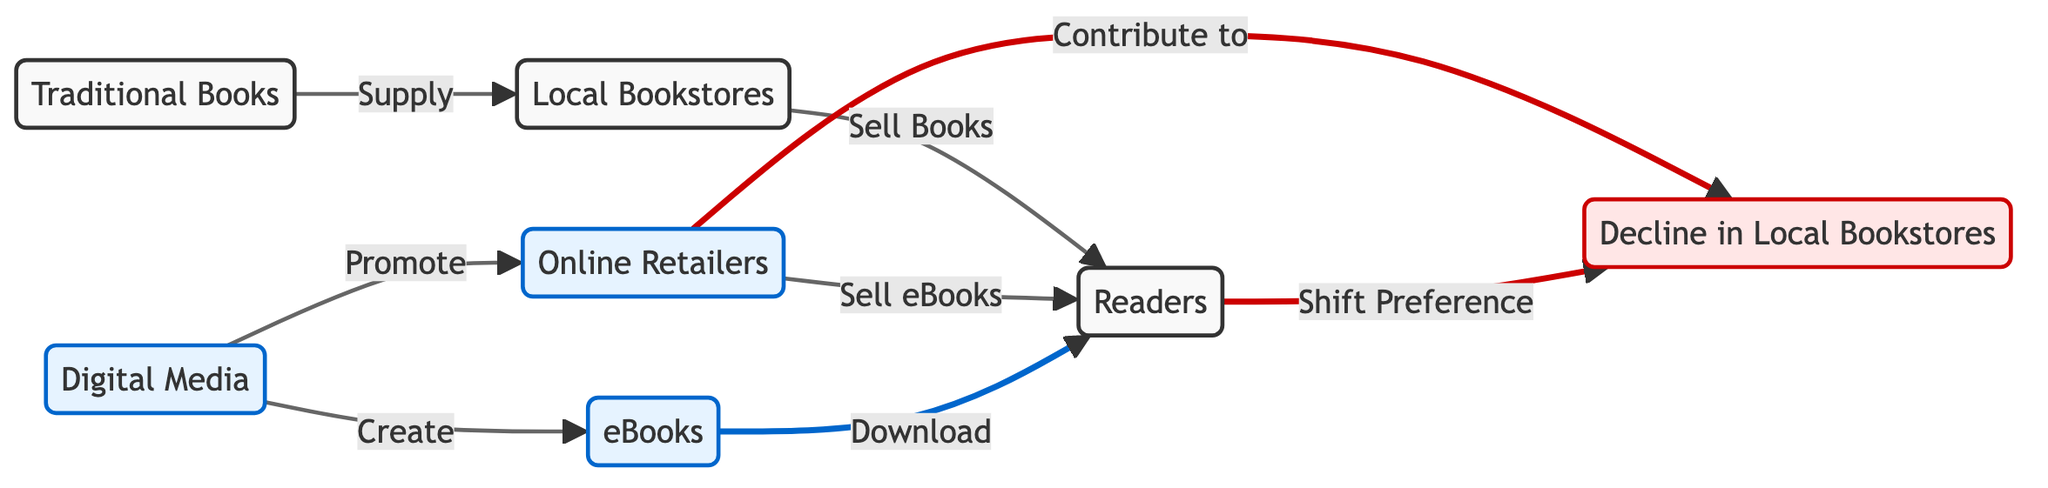What is the primary supply source for local bookstores? According to the diagram, local bookstores receive their supply directly from traditional books, as indicated by the arrow connecting the two.
Answer: Traditional Books How many main nodes are present in this diagram? By counting the distinct entities represented in the diagram, we can identify a total of seven nodes: Traditional Books, Local Bookstores, Digital Media, Online Retailers, eBooks, Readers, and Decline in Local Bookstores.
Answer: Seven Which node shows a decline in business? The diagram designates the "Decline in Local Bookstores" as the node reflecting a decrease in business, as indicated by its labeling and the specific class style applied to it.
Answer: Decline in Local Bookstores What two functions does digital media perform? The diagram clearly states that digital media performs two key functions: it promotes online retailers and creates eBooks, as shown by the two arrows emanating from the digital media node.
Answer: Promote and Create What happens to local bookstores as a result of readers shifting preferences? The diagram illustrates that a shift in reader preferences contributes to the decline of local bookstores, as indicated by the directional arrows connecting these nodes.
Answer: Decline in Local Bookstores How do online retailers impact local bookstores? Online retailers are shown to contribute to the decline of local bookstores in the diagram, which signifies that their business activities have a negative effect on the survival of local bookstores.
Answer: Decline How are eBooks distributed to readers? The diagram indicates that eBooks are downloaded by readers, highlighting the process through which digital content reaches its audience.
Answer: Download Which node is connected to both promoting and creating functions? The digital media node is uniquely responsible for both promoting online retailers and creating eBooks, as illustrated by the arrows pointing to each respective function.
Answer: Digital Media What is the relationship between readers and ebooks? The diagram shows that readers download eBooks, which establishes a direct relationship where the readers receive digital content through this action.
Answer: Download 